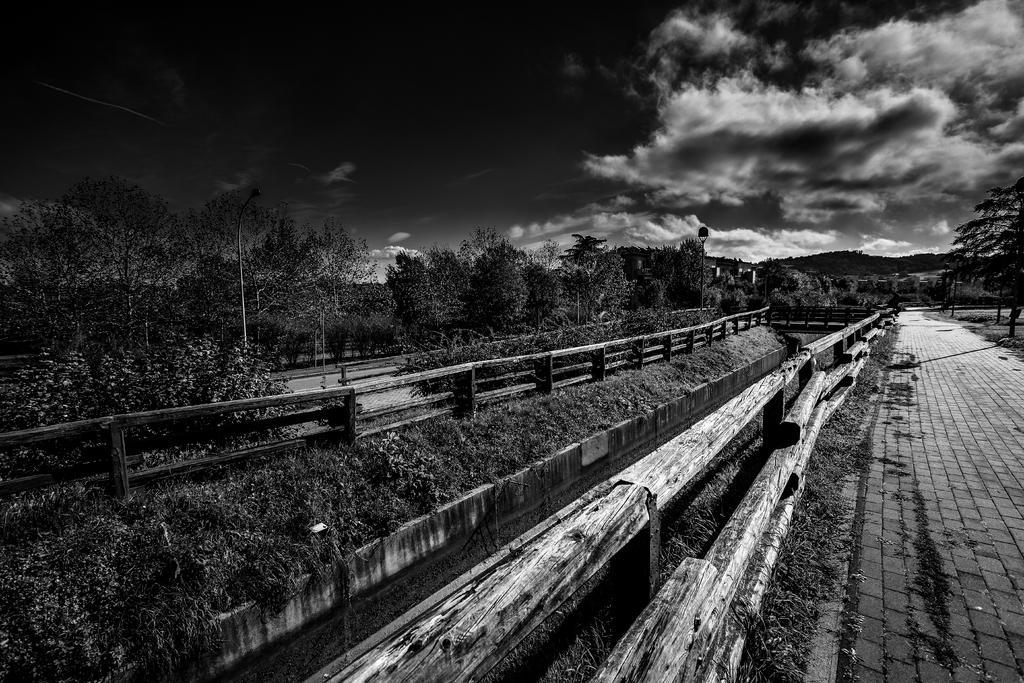In one or two sentences, can you explain what this image depicts? This is a black and white image. In this image we can see sky with clouds, street poles, street lights, trees, roads, grass and wooden fences. 